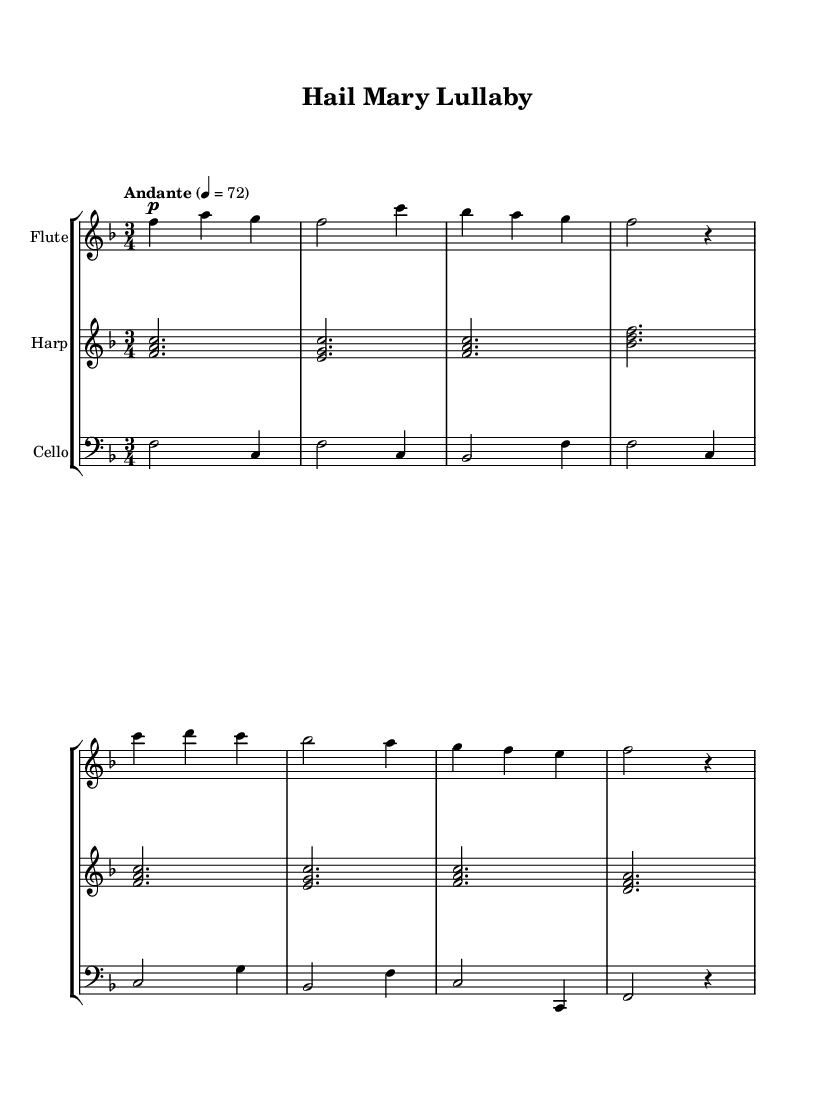What is the key signature of this music? The key signature has one flat, which indicates it is in F major. This can be identified by looking at the key signature at the beginning of the staff.
Answer: F major What is the time signature of this piece? The time signature is indicated at the beginning of the music with numbers, showing there are three beats in a measure. This can be found directly after the clef on the staff.
Answer: 3/4 What is the tempo marking for this lullaby? The tempo marking states "Andante," which indicates a moderately slow pace for the piece. This is typically found at the start of the music right after the time signature.
Answer: Andante How many measures are in the flute section? By counting the vertical lines (bar lines) that separate the measures in the flute part, there are a total of 8 measures. This counting is done from the beginning to the end of the flute's music.
Answer: 8 What dynamics are indicated for the cello part? The cello part includes a "p" marking, indicating that it should be played softly throughout. This dynamic marking appears at the beginning of the cello part.
Answer: Piano Which instruments are included in this composition? The score specifies three different instruments: flute, harp, and cello, each indicated on separate staves within the score. These instruments are labeled at the start of each staff.
Answer: Flute, Harp, Cello What is the last note played by the cello? The last note in the cello section is a whole note and is an F, as seen at the end of the bar before the final rest. This can be identified by examining the final measure of the cello part.
Answer: F 